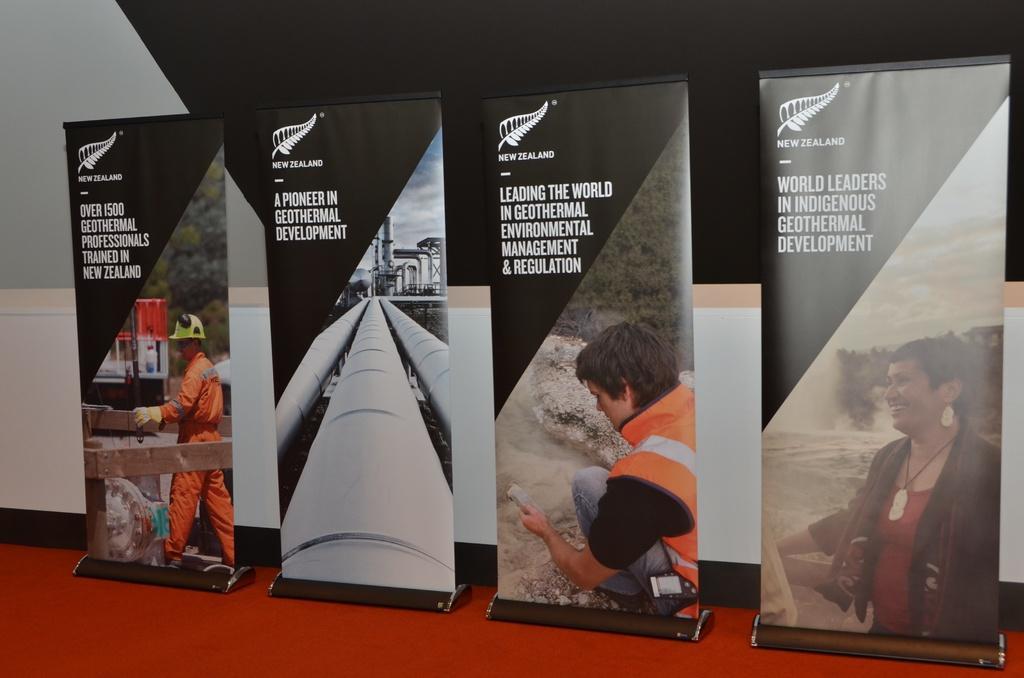Could you give a brief overview of what you see in this image? In this picture there are four banners which are placed near to the wall. At the bottom I can see the red carpet. On the right banner there was a woman who is standing near to the water flow. Beside that banner I can see the man who is the holding the mobile phone. On the left I can see the worker who is standing near to the wooden fencing. Beside that banner I can see the pipes and factory. 